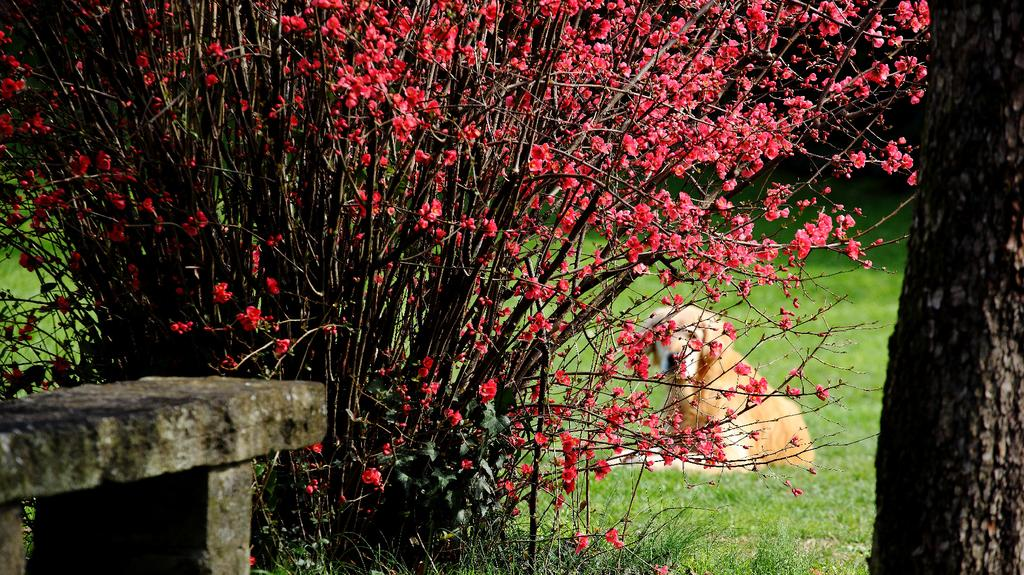What type of structure is present in the image? There is a stone platform in the image. What type of vegetation can be seen in the image? There are plants and flowers in the image. What animal is present in the image? There is a dog on the grass in the image. What object can be seen on the right side of the image? There is a branch on the right side of the image. What channel is the dog watching on the grass in the image? There is no television or channel present in the image; it features a dog on the grass. Who is the servant attending to in the image? There is no servant present in the image. 